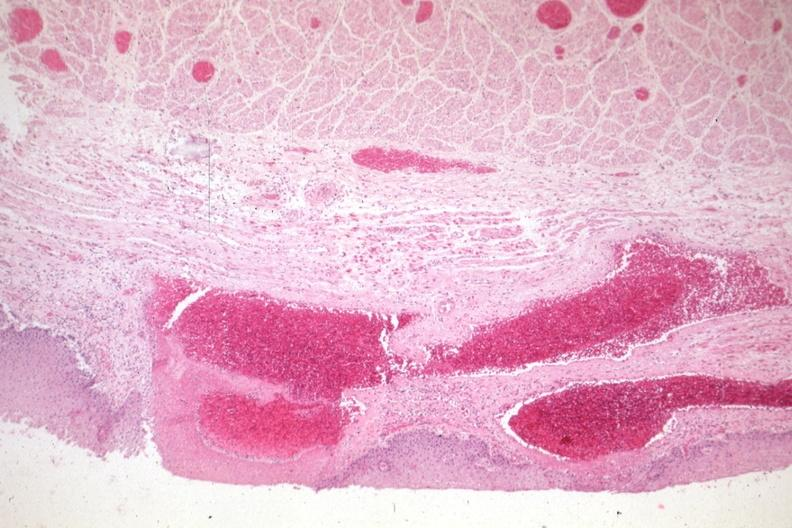what is present?
Answer the question using a single word or phrase. Esophagus 